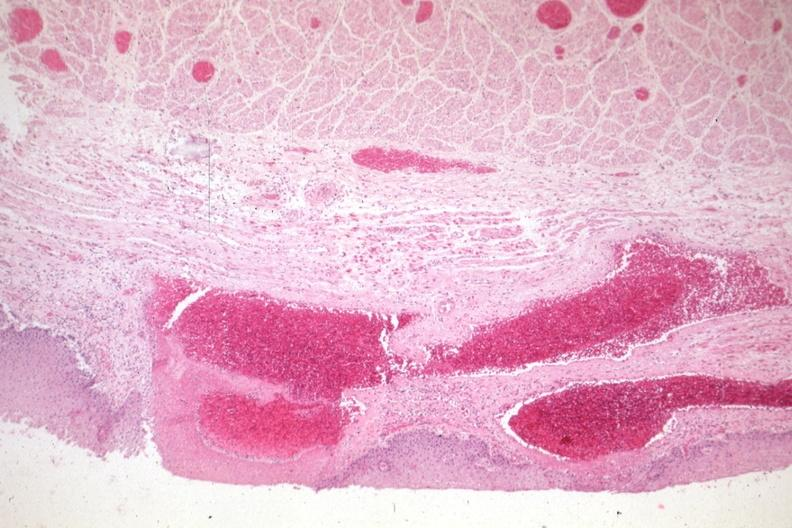what is present?
Answer the question using a single word or phrase. Esophagus 